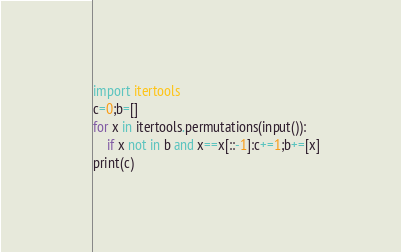Convert code to text. <code><loc_0><loc_0><loc_500><loc_500><_Python_>import itertools
c=0;b=[]
for x in itertools.permutations(input()):
    if x not in b and x==x[::-1]:c+=1;b+=[x]
print(c)</code> 